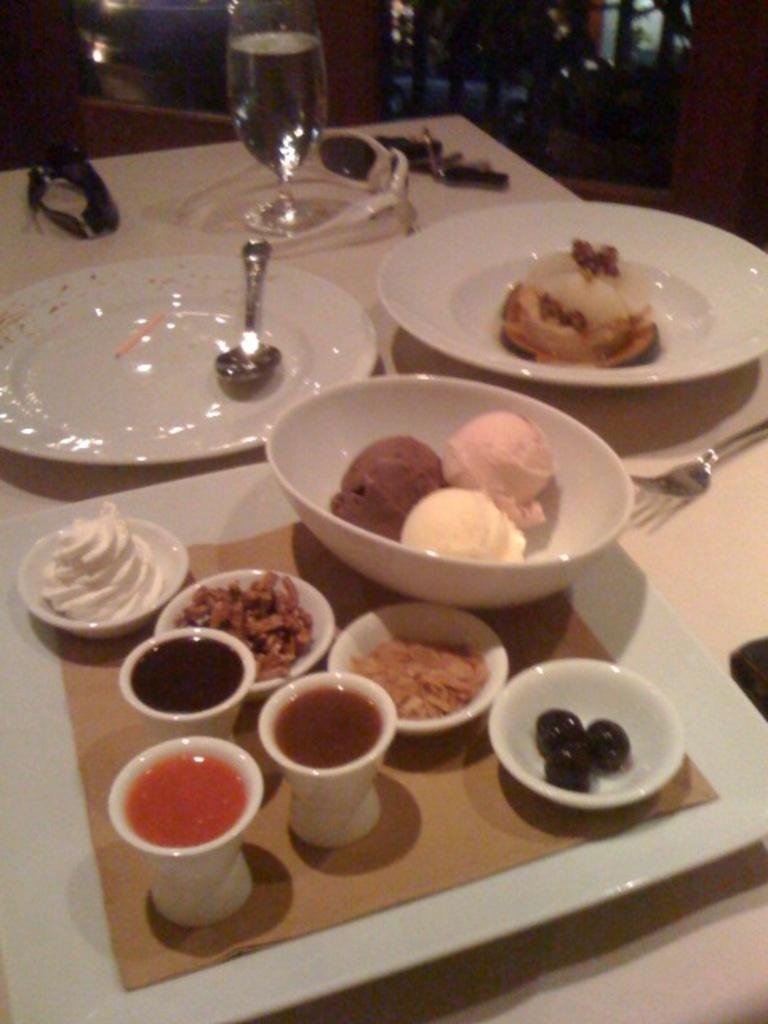What piece of furniture is present in the image? There is a table in the image. What can be found on the table? There are foods, a spoon, glasses, and a table mat on the table. What might be used for eating or drinking in the image? The spoon and glasses on the table might be used for eating or drinking. What is placed under the dishes to protect the table surface? The table mat on the table is placed under the dishes to protect the table surface. What type of cork is used to seal the glasses in the image? There is no cork present in the image; the glasses are not sealed. 